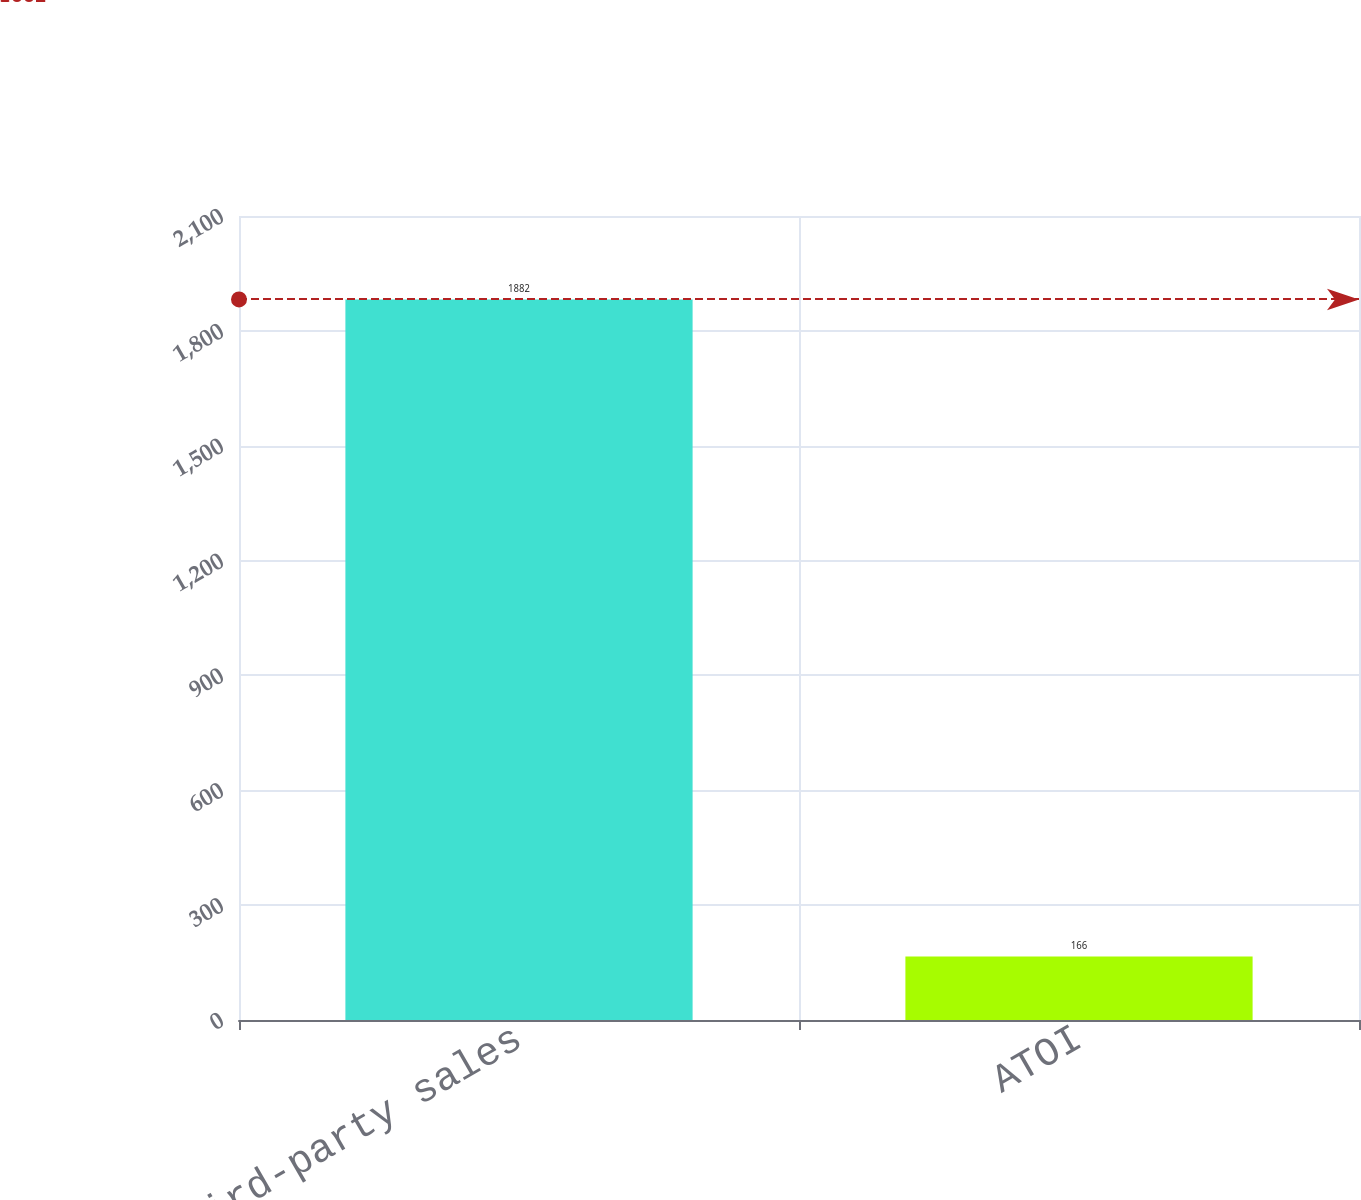<chart> <loc_0><loc_0><loc_500><loc_500><bar_chart><fcel>Third-party sales<fcel>ATOI<nl><fcel>1882<fcel>166<nl></chart> 